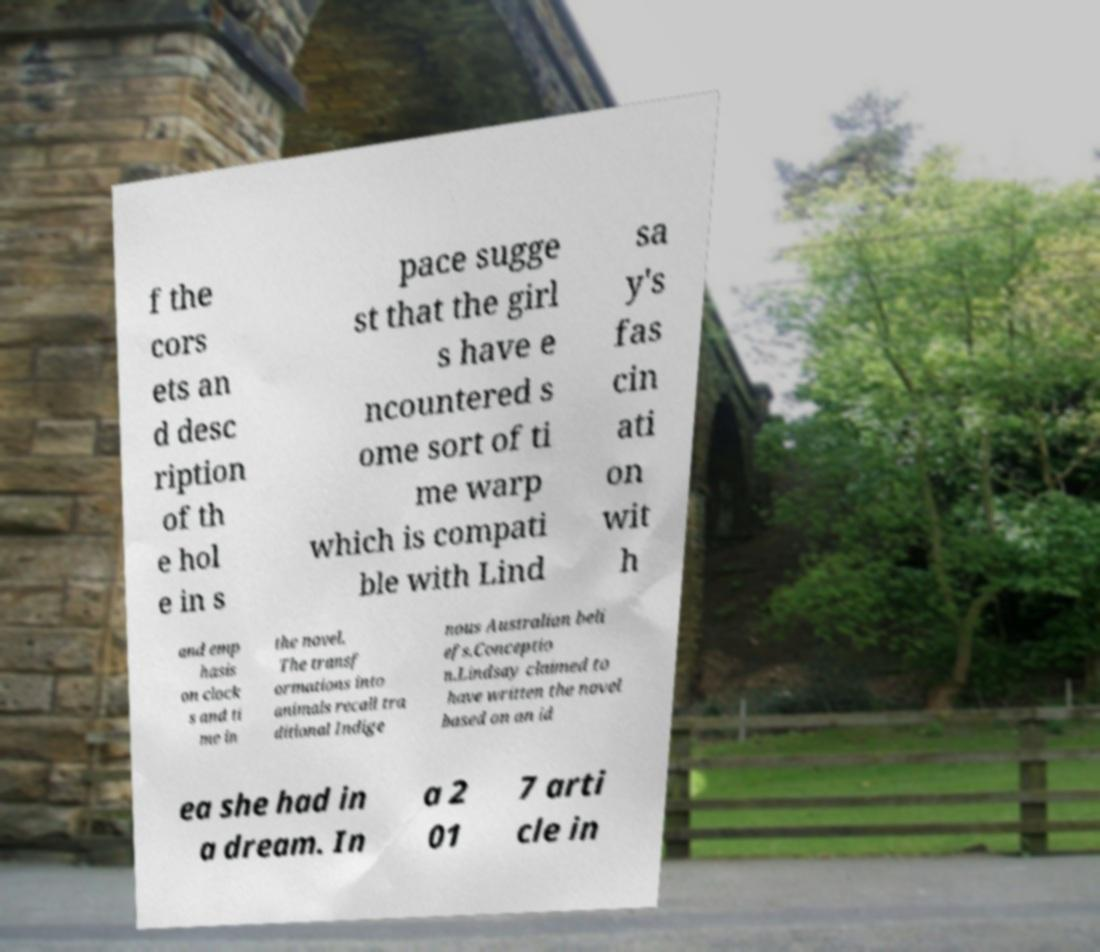Can you read and provide the text displayed in the image?This photo seems to have some interesting text. Can you extract and type it out for me? f the cors ets an d desc ription of th e hol e in s pace sugge st that the girl s have e ncountered s ome sort of ti me warp which is compati ble with Lind sa y's fas cin ati on wit h and emp hasis on clock s and ti me in the novel. The transf ormations into animals recall tra ditional Indige nous Australian beli efs.Conceptio n.Lindsay claimed to have written the novel based on an id ea she had in a dream. In a 2 01 7 arti cle in 